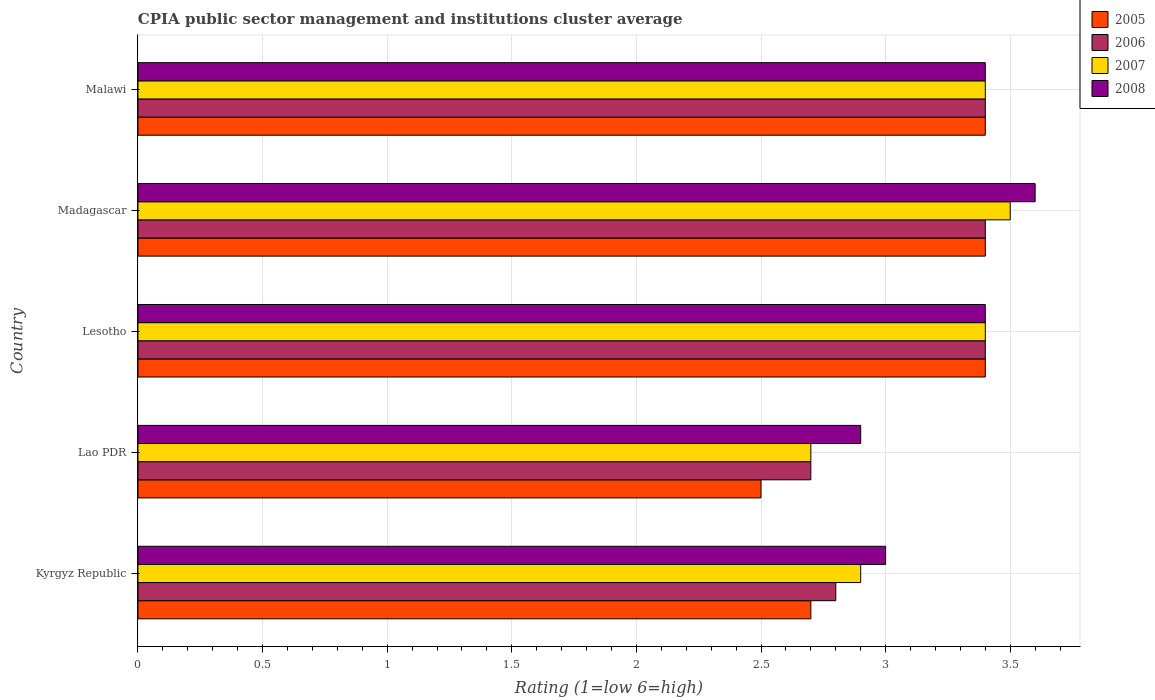How many different coloured bars are there?
Offer a very short reply. 4. How many groups of bars are there?
Your answer should be very brief. 5. Are the number of bars per tick equal to the number of legend labels?
Your answer should be compact. Yes. What is the label of the 5th group of bars from the top?
Your response must be concise. Kyrgyz Republic. Across all countries, what is the minimum CPIA rating in 2006?
Keep it short and to the point. 2.7. In which country was the CPIA rating in 2006 maximum?
Give a very brief answer. Lesotho. In which country was the CPIA rating in 2008 minimum?
Your answer should be very brief. Lao PDR. What is the total CPIA rating in 2005 in the graph?
Keep it short and to the point. 15.4. What is the difference between the CPIA rating in 2005 in Kyrgyz Republic and that in Lao PDR?
Keep it short and to the point. 0.2. What is the difference between the CPIA rating in 2006 in Kyrgyz Republic and the CPIA rating in 2008 in Madagascar?
Your answer should be compact. -0.8. What is the average CPIA rating in 2006 per country?
Provide a succinct answer. 3.14. What is the ratio of the CPIA rating in 2006 in Madagascar to that in Malawi?
Ensure brevity in your answer.  1. Is the CPIA rating in 2005 in Lao PDR less than that in Malawi?
Your response must be concise. Yes. Is the difference between the CPIA rating in 2006 in Lao PDR and Malawi greater than the difference between the CPIA rating in 2007 in Lao PDR and Malawi?
Your answer should be compact. No. What is the difference between the highest and the second highest CPIA rating in 2007?
Give a very brief answer. 0.1. What is the difference between the highest and the lowest CPIA rating in 2008?
Provide a short and direct response. 0.7. Is it the case that in every country, the sum of the CPIA rating in 2005 and CPIA rating in 2008 is greater than the CPIA rating in 2006?
Provide a succinct answer. Yes. Does the graph contain any zero values?
Provide a short and direct response. No. How many legend labels are there?
Your response must be concise. 4. What is the title of the graph?
Give a very brief answer. CPIA public sector management and institutions cluster average. What is the label or title of the X-axis?
Keep it short and to the point. Rating (1=low 6=high). What is the Rating (1=low 6=high) in 2005 in Kyrgyz Republic?
Keep it short and to the point. 2.7. What is the Rating (1=low 6=high) in 2006 in Kyrgyz Republic?
Offer a very short reply. 2.8. What is the Rating (1=low 6=high) in 2007 in Kyrgyz Republic?
Ensure brevity in your answer.  2.9. What is the Rating (1=low 6=high) of 2005 in Lao PDR?
Keep it short and to the point. 2.5. What is the Rating (1=low 6=high) of 2007 in Lao PDR?
Offer a very short reply. 2.7. What is the Rating (1=low 6=high) in 2005 in Lesotho?
Keep it short and to the point. 3.4. What is the Rating (1=low 6=high) of 2006 in Madagascar?
Ensure brevity in your answer.  3.4. What is the Rating (1=low 6=high) of 2007 in Madagascar?
Offer a very short reply. 3.5. What is the Rating (1=low 6=high) in 2005 in Malawi?
Give a very brief answer. 3.4. What is the Rating (1=low 6=high) in 2007 in Malawi?
Your answer should be very brief. 3.4. What is the Rating (1=low 6=high) of 2008 in Malawi?
Offer a terse response. 3.4. Across all countries, what is the maximum Rating (1=low 6=high) in 2005?
Make the answer very short. 3.4. Across all countries, what is the maximum Rating (1=low 6=high) in 2006?
Offer a very short reply. 3.4. Across all countries, what is the maximum Rating (1=low 6=high) in 2008?
Your response must be concise. 3.6. Across all countries, what is the minimum Rating (1=low 6=high) of 2006?
Keep it short and to the point. 2.7. Across all countries, what is the minimum Rating (1=low 6=high) in 2007?
Give a very brief answer. 2.7. Across all countries, what is the minimum Rating (1=low 6=high) in 2008?
Provide a succinct answer. 2.9. What is the difference between the Rating (1=low 6=high) of 2005 in Kyrgyz Republic and that in Lao PDR?
Offer a terse response. 0.2. What is the difference between the Rating (1=low 6=high) of 2006 in Kyrgyz Republic and that in Lao PDR?
Give a very brief answer. 0.1. What is the difference between the Rating (1=low 6=high) of 2007 in Kyrgyz Republic and that in Lao PDR?
Offer a very short reply. 0.2. What is the difference between the Rating (1=low 6=high) of 2005 in Kyrgyz Republic and that in Lesotho?
Provide a short and direct response. -0.7. What is the difference between the Rating (1=low 6=high) of 2007 in Kyrgyz Republic and that in Lesotho?
Provide a short and direct response. -0.5. What is the difference between the Rating (1=low 6=high) of 2008 in Kyrgyz Republic and that in Lesotho?
Provide a succinct answer. -0.4. What is the difference between the Rating (1=low 6=high) of 2007 in Kyrgyz Republic and that in Madagascar?
Ensure brevity in your answer.  -0.6. What is the difference between the Rating (1=low 6=high) in 2008 in Kyrgyz Republic and that in Madagascar?
Keep it short and to the point. -0.6. What is the difference between the Rating (1=low 6=high) in 2005 in Kyrgyz Republic and that in Malawi?
Ensure brevity in your answer.  -0.7. What is the difference between the Rating (1=low 6=high) in 2007 in Kyrgyz Republic and that in Malawi?
Your response must be concise. -0.5. What is the difference between the Rating (1=low 6=high) of 2005 in Lao PDR and that in Lesotho?
Keep it short and to the point. -0.9. What is the difference between the Rating (1=low 6=high) in 2008 in Lao PDR and that in Lesotho?
Offer a terse response. -0.5. What is the difference between the Rating (1=low 6=high) in 2005 in Lao PDR and that in Madagascar?
Your answer should be very brief. -0.9. What is the difference between the Rating (1=low 6=high) in 2007 in Lao PDR and that in Madagascar?
Offer a terse response. -0.8. What is the difference between the Rating (1=low 6=high) of 2008 in Lao PDR and that in Madagascar?
Provide a succinct answer. -0.7. What is the difference between the Rating (1=low 6=high) of 2005 in Lao PDR and that in Malawi?
Provide a succinct answer. -0.9. What is the difference between the Rating (1=low 6=high) in 2008 in Lao PDR and that in Malawi?
Keep it short and to the point. -0.5. What is the difference between the Rating (1=low 6=high) in 2005 in Lesotho and that in Madagascar?
Your response must be concise. 0. What is the difference between the Rating (1=low 6=high) of 2007 in Lesotho and that in Madagascar?
Provide a succinct answer. -0.1. What is the difference between the Rating (1=low 6=high) in 2008 in Lesotho and that in Madagascar?
Your answer should be compact. -0.2. What is the difference between the Rating (1=low 6=high) of 2008 in Lesotho and that in Malawi?
Offer a very short reply. 0. What is the difference between the Rating (1=low 6=high) of 2006 in Madagascar and that in Malawi?
Provide a succinct answer. 0. What is the difference between the Rating (1=low 6=high) of 2007 in Madagascar and that in Malawi?
Your response must be concise. 0.1. What is the difference between the Rating (1=low 6=high) in 2008 in Madagascar and that in Malawi?
Provide a short and direct response. 0.2. What is the difference between the Rating (1=low 6=high) in 2005 in Kyrgyz Republic and the Rating (1=low 6=high) in 2008 in Lao PDR?
Provide a succinct answer. -0.2. What is the difference between the Rating (1=low 6=high) of 2007 in Kyrgyz Republic and the Rating (1=low 6=high) of 2008 in Lao PDR?
Keep it short and to the point. 0. What is the difference between the Rating (1=low 6=high) of 2005 in Kyrgyz Republic and the Rating (1=low 6=high) of 2006 in Lesotho?
Give a very brief answer. -0.7. What is the difference between the Rating (1=low 6=high) in 2005 in Kyrgyz Republic and the Rating (1=low 6=high) in 2007 in Lesotho?
Keep it short and to the point. -0.7. What is the difference between the Rating (1=low 6=high) in 2006 in Kyrgyz Republic and the Rating (1=low 6=high) in 2007 in Lesotho?
Give a very brief answer. -0.6. What is the difference between the Rating (1=low 6=high) in 2006 in Kyrgyz Republic and the Rating (1=low 6=high) in 2008 in Lesotho?
Offer a terse response. -0.6. What is the difference between the Rating (1=low 6=high) of 2005 in Kyrgyz Republic and the Rating (1=low 6=high) of 2008 in Madagascar?
Make the answer very short. -0.9. What is the difference between the Rating (1=low 6=high) of 2006 in Kyrgyz Republic and the Rating (1=low 6=high) of 2007 in Madagascar?
Make the answer very short. -0.7. What is the difference between the Rating (1=low 6=high) in 2006 in Kyrgyz Republic and the Rating (1=low 6=high) in 2008 in Madagascar?
Keep it short and to the point. -0.8. What is the difference between the Rating (1=low 6=high) in 2005 in Kyrgyz Republic and the Rating (1=low 6=high) in 2006 in Malawi?
Provide a short and direct response. -0.7. What is the difference between the Rating (1=low 6=high) in 2006 in Kyrgyz Republic and the Rating (1=low 6=high) in 2007 in Malawi?
Offer a very short reply. -0.6. What is the difference between the Rating (1=low 6=high) of 2006 in Kyrgyz Republic and the Rating (1=low 6=high) of 2008 in Malawi?
Offer a very short reply. -0.6. What is the difference between the Rating (1=low 6=high) in 2007 in Kyrgyz Republic and the Rating (1=low 6=high) in 2008 in Malawi?
Your response must be concise. -0.5. What is the difference between the Rating (1=low 6=high) in 2005 in Lao PDR and the Rating (1=low 6=high) in 2008 in Lesotho?
Provide a short and direct response. -0.9. What is the difference between the Rating (1=low 6=high) of 2007 in Lao PDR and the Rating (1=low 6=high) of 2008 in Lesotho?
Offer a terse response. -0.7. What is the difference between the Rating (1=low 6=high) of 2005 in Lao PDR and the Rating (1=low 6=high) of 2008 in Madagascar?
Ensure brevity in your answer.  -1.1. What is the difference between the Rating (1=low 6=high) of 2006 in Lao PDR and the Rating (1=low 6=high) of 2008 in Madagascar?
Give a very brief answer. -0.9. What is the difference between the Rating (1=low 6=high) in 2007 in Lao PDR and the Rating (1=low 6=high) in 2008 in Madagascar?
Your answer should be very brief. -0.9. What is the difference between the Rating (1=low 6=high) in 2005 in Lao PDR and the Rating (1=low 6=high) in 2007 in Malawi?
Your answer should be compact. -0.9. What is the difference between the Rating (1=low 6=high) in 2005 in Lao PDR and the Rating (1=low 6=high) in 2008 in Malawi?
Offer a very short reply. -0.9. What is the difference between the Rating (1=low 6=high) of 2006 in Lao PDR and the Rating (1=low 6=high) of 2007 in Malawi?
Your answer should be very brief. -0.7. What is the difference between the Rating (1=low 6=high) in 2007 in Lao PDR and the Rating (1=low 6=high) in 2008 in Malawi?
Provide a succinct answer. -0.7. What is the difference between the Rating (1=low 6=high) of 2005 in Lesotho and the Rating (1=low 6=high) of 2006 in Malawi?
Provide a short and direct response. 0. What is the difference between the Rating (1=low 6=high) of 2005 in Lesotho and the Rating (1=low 6=high) of 2008 in Malawi?
Offer a terse response. 0. What is the difference between the Rating (1=low 6=high) of 2006 in Lesotho and the Rating (1=low 6=high) of 2007 in Malawi?
Give a very brief answer. 0. What is the difference between the Rating (1=low 6=high) in 2007 in Lesotho and the Rating (1=low 6=high) in 2008 in Malawi?
Your answer should be very brief. 0. What is the difference between the Rating (1=low 6=high) in 2005 in Madagascar and the Rating (1=low 6=high) in 2006 in Malawi?
Your response must be concise. 0. What is the average Rating (1=low 6=high) of 2005 per country?
Ensure brevity in your answer.  3.08. What is the average Rating (1=low 6=high) of 2006 per country?
Provide a succinct answer. 3.14. What is the average Rating (1=low 6=high) of 2007 per country?
Provide a short and direct response. 3.18. What is the average Rating (1=low 6=high) of 2008 per country?
Give a very brief answer. 3.26. What is the difference between the Rating (1=low 6=high) in 2005 and Rating (1=low 6=high) in 2006 in Kyrgyz Republic?
Your answer should be very brief. -0.1. What is the difference between the Rating (1=low 6=high) in 2005 and Rating (1=low 6=high) in 2007 in Kyrgyz Republic?
Offer a terse response. -0.2. What is the difference between the Rating (1=low 6=high) in 2005 and Rating (1=low 6=high) in 2006 in Lao PDR?
Ensure brevity in your answer.  -0.2. What is the difference between the Rating (1=low 6=high) in 2005 and Rating (1=low 6=high) in 2007 in Lao PDR?
Your answer should be compact. -0.2. What is the difference between the Rating (1=low 6=high) of 2005 and Rating (1=low 6=high) of 2008 in Lao PDR?
Offer a very short reply. -0.4. What is the difference between the Rating (1=low 6=high) of 2006 and Rating (1=low 6=high) of 2008 in Lao PDR?
Ensure brevity in your answer.  -0.2. What is the difference between the Rating (1=low 6=high) in 2007 and Rating (1=low 6=high) in 2008 in Lao PDR?
Provide a succinct answer. -0.2. What is the difference between the Rating (1=low 6=high) of 2006 and Rating (1=low 6=high) of 2008 in Lesotho?
Provide a succinct answer. 0. What is the difference between the Rating (1=low 6=high) of 2006 and Rating (1=low 6=high) of 2008 in Madagascar?
Offer a terse response. -0.2. What is the difference between the Rating (1=low 6=high) in 2007 and Rating (1=low 6=high) in 2008 in Madagascar?
Keep it short and to the point. -0.1. What is the difference between the Rating (1=low 6=high) in 2005 and Rating (1=low 6=high) in 2006 in Malawi?
Make the answer very short. 0. What is the difference between the Rating (1=low 6=high) of 2005 and Rating (1=low 6=high) of 2008 in Malawi?
Give a very brief answer. 0. What is the difference between the Rating (1=low 6=high) in 2006 and Rating (1=low 6=high) in 2007 in Malawi?
Ensure brevity in your answer.  0. What is the difference between the Rating (1=low 6=high) of 2007 and Rating (1=low 6=high) of 2008 in Malawi?
Provide a short and direct response. 0. What is the ratio of the Rating (1=low 6=high) of 2005 in Kyrgyz Republic to that in Lao PDR?
Provide a short and direct response. 1.08. What is the ratio of the Rating (1=low 6=high) of 2007 in Kyrgyz Republic to that in Lao PDR?
Give a very brief answer. 1.07. What is the ratio of the Rating (1=low 6=high) of 2008 in Kyrgyz Republic to that in Lao PDR?
Your answer should be compact. 1.03. What is the ratio of the Rating (1=low 6=high) in 2005 in Kyrgyz Republic to that in Lesotho?
Make the answer very short. 0.79. What is the ratio of the Rating (1=low 6=high) in 2006 in Kyrgyz Republic to that in Lesotho?
Ensure brevity in your answer.  0.82. What is the ratio of the Rating (1=low 6=high) of 2007 in Kyrgyz Republic to that in Lesotho?
Your answer should be very brief. 0.85. What is the ratio of the Rating (1=low 6=high) of 2008 in Kyrgyz Republic to that in Lesotho?
Your response must be concise. 0.88. What is the ratio of the Rating (1=low 6=high) of 2005 in Kyrgyz Republic to that in Madagascar?
Offer a terse response. 0.79. What is the ratio of the Rating (1=low 6=high) in 2006 in Kyrgyz Republic to that in Madagascar?
Offer a terse response. 0.82. What is the ratio of the Rating (1=low 6=high) in 2007 in Kyrgyz Republic to that in Madagascar?
Give a very brief answer. 0.83. What is the ratio of the Rating (1=low 6=high) of 2005 in Kyrgyz Republic to that in Malawi?
Offer a very short reply. 0.79. What is the ratio of the Rating (1=low 6=high) of 2006 in Kyrgyz Republic to that in Malawi?
Your answer should be very brief. 0.82. What is the ratio of the Rating (1=low 6=high) of 2007 in Kyrgyz Republic to that in Malawi?
Provide a short and direct response. 0.85. What is the ratio of the Rating (1=low 6=high) in 2008 in Kyrgyz Republic to that in Malawi?
Give a very brief answer. 0.88. What is the ratio of the Rating (1=low 6=high) in 2005 in Lao PDR to that in Lesotho?
Ensure brevity in your answer.  0.74. What is the ratio of the Rating (1=low 6=high) of 2006 in Lao PDR to that in Lesotho?
Offer a very short reply. 0.79. What is the ratio of the Rating (1=low 6=high) in 2007 in Lao PDR to that in Lesotho?
Offer a very short reply. 0.79. What is the ratio of the Rating (1=low 6=high) in 2008 in Lao PDR to that in Lesotho?
Offer a terse response. 0.85. What is the ratio of the Rating (1=low 6=high) in 2005 in Lao PDR to that in Madagascar?
Provide a succinct answer. 0.74. What is the ratio of the Rating (1=low 6=high) in 2006 in Lao PDR to that in Madagascar?
Provide a succinct answer. 0.79. What is the ratio of the Rating (1=low 6=high) of 2007 in Lao PDR to that in Madagascar?
Your answer should be very brief. 0.77. What is the ratio of the Rating (1=low 6=high) in 2008 in Lao PDR to that in Madagascar?
Offer a terse response. 0.81. What is the ratio of the Rating (1=low 6=high) of 2005 in Lao PDR to that in Malawi?
Ensure brevity in your answer.  0.74. What is the ratio of the Rating (1=low 6=high) in 2006 in Lao PDR to that in Malawi?
Offer a very short reply. 0.79. What is the ratio of the Rating (1=low 6=high) of 2007 in Lao PDR to that in Malawi?
Provide a succinct answer. 0.79. What is the ratio of the Rating (1=low 6=high) of 2008 in Lao PDR to that in Malawi?
Your response must be concise. 0.85. What is the ratio of the Rating (1=low 6=high) in 2006 in Lesotho to that in Madagascar?
Give a very brief answer. 1. What is the ratio of the Rating (1=low 6=high) in 2007 in Lesotho to that in Madagascar?
Your answer should be compact. 0.97. What is the ratio of the Rating (1=low 6=high) of 2006 in Lesotho to that in Malawi?
Ensure brevity in your answer.  1. What is the ratio of the Rating (1=low 6=high) in 2007 in Lesotho to that in Malawi?
Offer a terse response. 1. What is the ratio of the Rating (1=low 6=high) of 2005 in Madagascar to that in Malawi?
Ensure brevity in your answer.  1. What is the ratio of the Rating (1=low 6=high) of 2007 in Madagascar to that in Malawi?
Ensure brevity in your answer.  1.03. What is the ratio of the Rating (1=low 6=high) of 2008 in Madagascar to that in Malawi?
Provide a short and direct response. 1.06. What is the difference between the highest and the second highest Rating (1=low 6=high) in 2005?
Ensure brevity in your answer.  0. What is the difference between the highest and the second highest Rating (1=low 6=high) in 2007?
Your answer should be compact. 0.1. What is the difference between the highest and the second highest Rating (1=low 6=high) of 2008?
Keep it short and to the point. 0.2. What is the difference between the highest and the lowest Rating (1=low 6=high) in 2006?
Provide a succinct answer. 0.7. What is the difference between the highest and the lowest Rating (1=low 6=high) of 2008?
Provide a short and direct response. 0.7. 